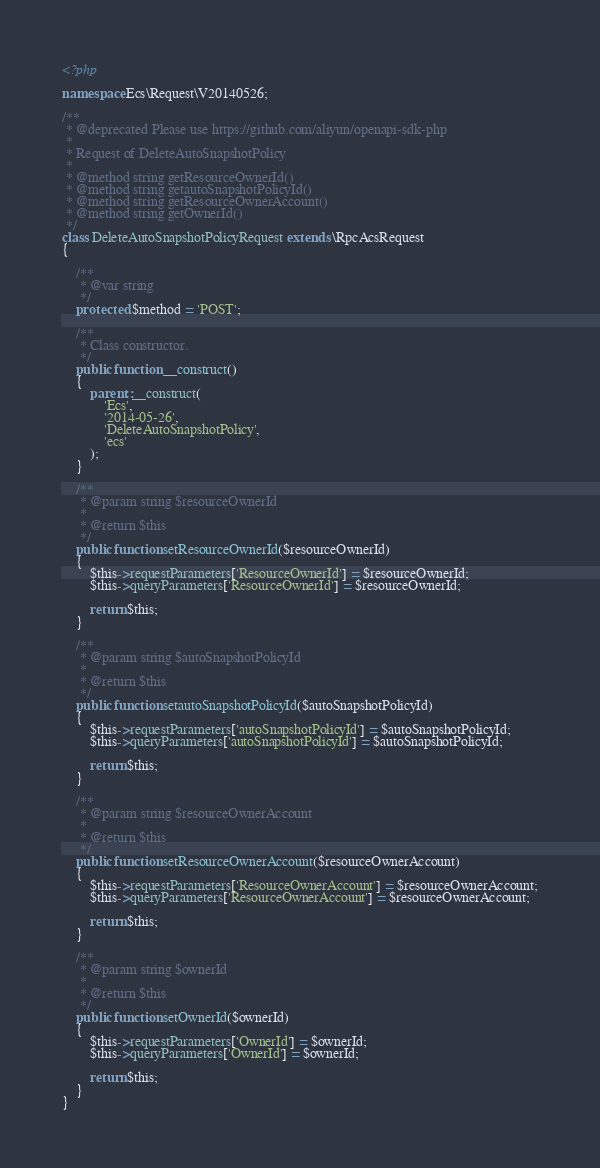Convert code to text. <code><loc_0><loc_0><loc_500><loc_500><_PHP_><?php

namespace Ecs\Request\V20140526;

/**
 * @deprecated Please use https://github.com/aliyun/openapi-sdk-php
 *
 * Request of DeleteAutoSnapshotPolicy
 *
 * @method string getResourceOwnerId()
 * @method string getautoSnapshotPolicyId()
 * @method string getResourceOwnerAccount()
 * @method string getOwnerId()
 */
class DeleteAutoSnapshotPolicyRequest extends \RpcAcsRequest
{

    /**
     * @var string
     */
    protected $method = 'POST';

    /**
     * Class constructor.
     */
    public function __construct()
    {
        parent::__construct(
            'Ecs',
            '2014-05-26',
            'DeleteAutoSnapshotPolicy',
            'ecs'
        );
    }

    /**
     * @param string $resourceOwnerId
     *
     * @return $this
     */
    public function setResourceOwnerId($resourceOwnerId)
    {
        $this->requestParameters['ResourceOwnerId'] = $resourceOwnerId;
        $this->queryParameters['ResourceOwnerId'] = $resourceOwnerId;

        return $this;
    }

    /**
     * @param string $autoSnapshotPolicyId
     *
     * @return $this
     */
    public function setautoSnapshotPolicyId($autoSnapshotPolicyId)
    {
        $this->requestParameters['autoSnapshotPolicyId'] = $autoSnapshotPolicyId;
        $this->queryParameters['autoSnapshotPolicyId'] = $autoSnapshotPolicyId;

        return $this;
    }

    /**
     * @param string $resourceOwnerAccount
     *
     * @return $this
     */
    public function setResourceOwnerAccount($resourceOwnerAccount)
    {
        $this->requestParameters['ResourceOwnerAccount'] = $resourceOwnerAccount;
        $this->queryParameters['ResourceOwnerAccount'] = $resourceOwnerAccount;

        return $this;
    }

    /**
     * @param string $ownerId
     *
     * @return $this
     */
    public function setOwnerId($ownerId)
    {
        $this->requestParameters['OwnerId'] = $ownerId;
        $this->queryParameters['OwnerId'] = $ownerId;

        return $this;
    }
}
</code> 